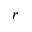Convert formula to latex. <formula><loc_0><loc_0><loc_500><loc_500>r</formula> 